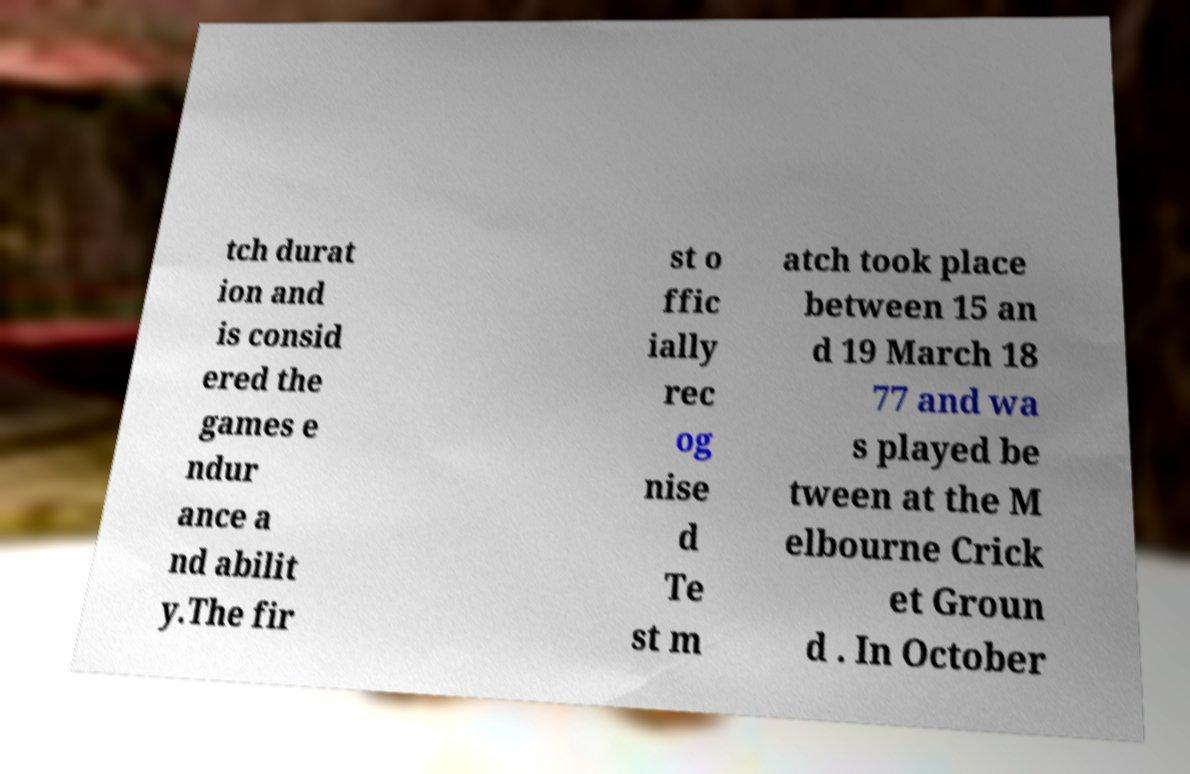Could you extract and type out the text from this image? tch durat ion and is consid ered the games e ndur ance a nd abilit y.The fir st o ffic ially rec og nise d Te st m atch took place between 15 an d 19 March 18 77 and wa s played be tween at the M elbourne Crick et Groun d . In October 